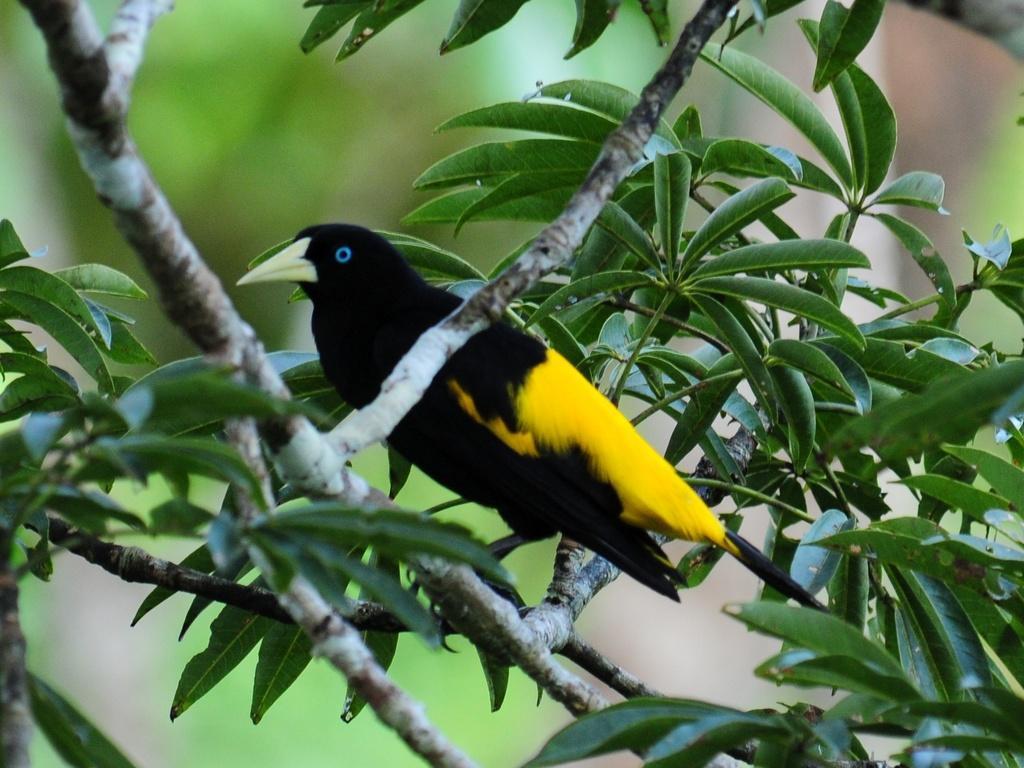Can you describe this image briefly? In this picture we can see a bird on a branch of a tree and in the background it is blurry. 